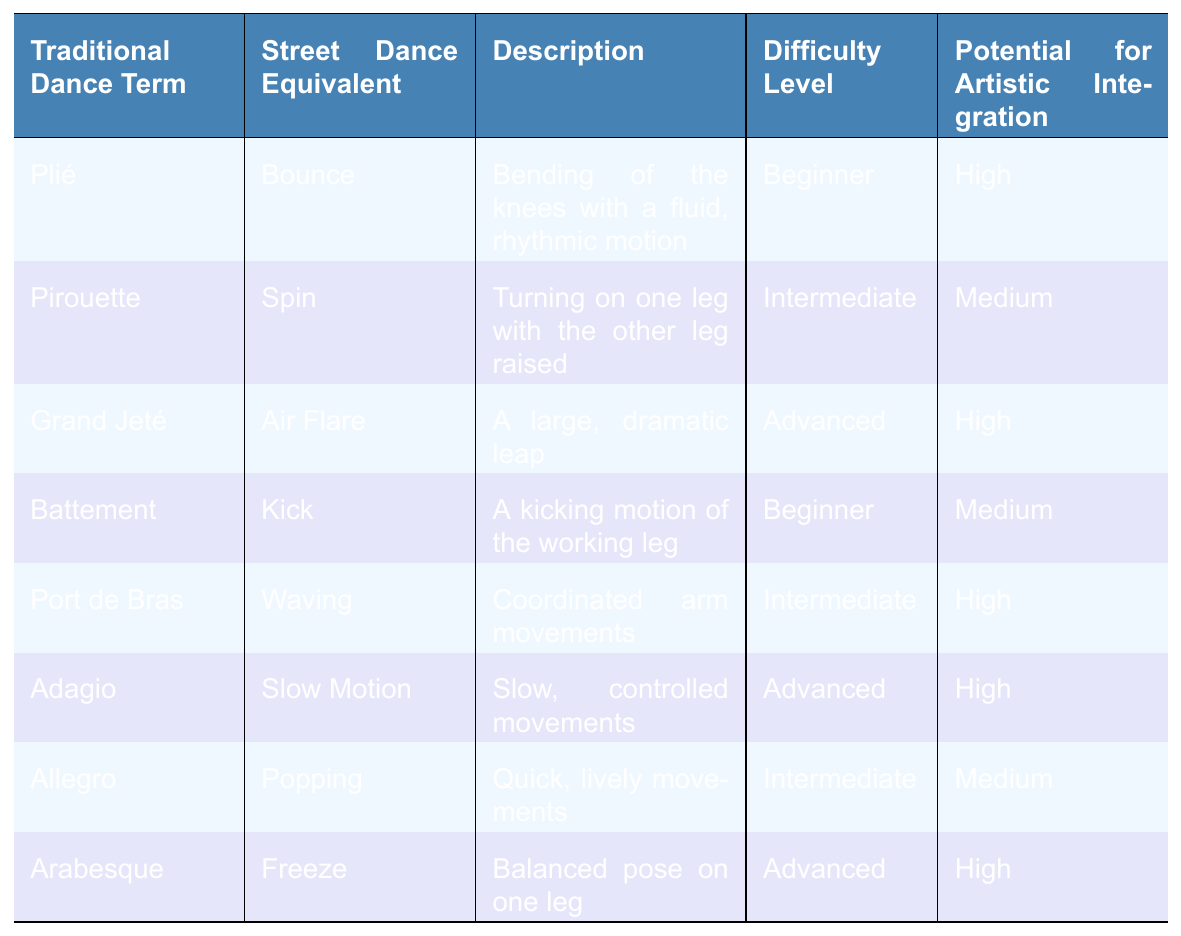What is the street dance equivalent of "Plié"? The table indicates that the street dance equivalent of "Plié" is "Bounce".
Answer: Bounce What is the difficulty level of "Arabesque"? According to the table, the difficulty level of "Arabesque" is "Advanced".
Answer: Advanced Which traditional dance term has a "Medium" potential for artistic integration? The table shows that "Pirouette" and "Battement" both have "Medium" potential for artistic integration.
Answer: Pirouette, Battement What is the description of "Grand Jeté"? The table describes "Grand Jeté" as "A large, dramatic leap".
Answer: A large, dramatic leap Is the street dance equivalent of "Adagio" likely to be easy for a beginner? The street dance equivalent of "Adagio" is "Slow Motion", which is classified as "Advanced" in difficulty. Therefore, it is not likely to be easy for a beginner.
Answer: No Which traditional dance term has the highest potential for artistic integration? The terms "Plié", "Grand Jeté", "Port de Bras", "Adagio", and "Arabesque" all have "High" potential for artistic integration, so more than one term qualifies.
Answer: Plié, Grand Jeté, Port de Bras, Adagio, Arabesque How many traditional dance terms are classified as beginner difficulty? The table lists "Plié" and "Battement" as beginner terms; thus there are two.
Answer: 2 What is the average difficulty level of the traditional dance terms in the table? The levels are Beginner (2), Intermediate (3), and Advanced (3). By counting the levels numerically (Beginner=1, Intermediate=2, Advanced=3), we compute (2*1 + 3*2 + 3*3) / 8 = 2.25, translating to Intermediate.
Answer: Intermediate Which street dance equivalent corresponds to the "Kick" traditional term? The table indicates that the traditional dance term "Battement" is equivalent to "Kick".
Answer: Kick If a dancer is skilled in "Spin", how does their difficulty level compare to that of "Bounce"? "Spin" is classified as "Intermediate" difficulty, while "Bounce" is classified as "Beginner". Therefore, "Spin" is more difficult than "Bounce".
Answer: More difficult 